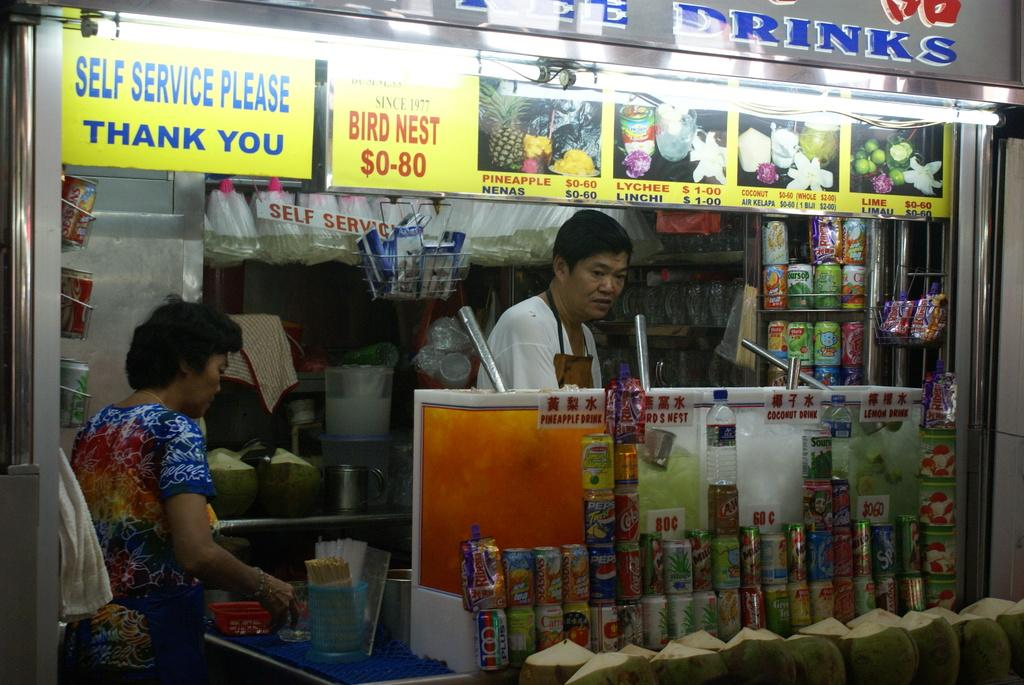Provide a one-sentence caption for the provided image. Man working behidn a stall that says Drinks on it. 